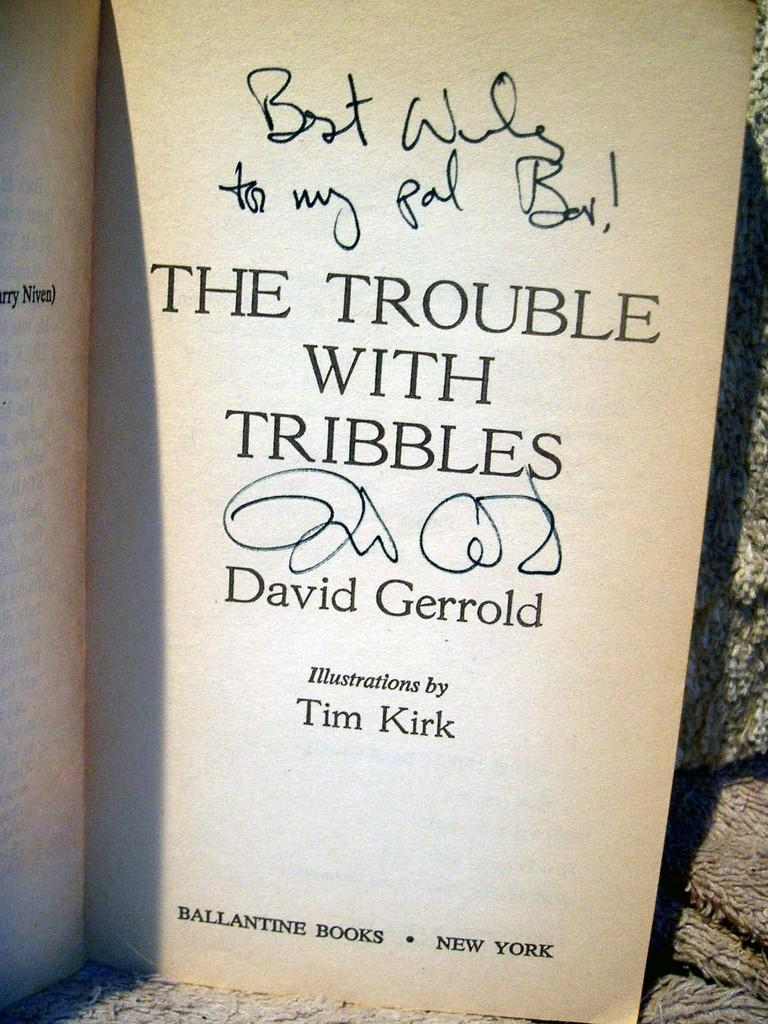<image>
Summarize the visual content of the image. A book called the "Troubles with Tribbles" by Thomas Kirk that was a gift. 